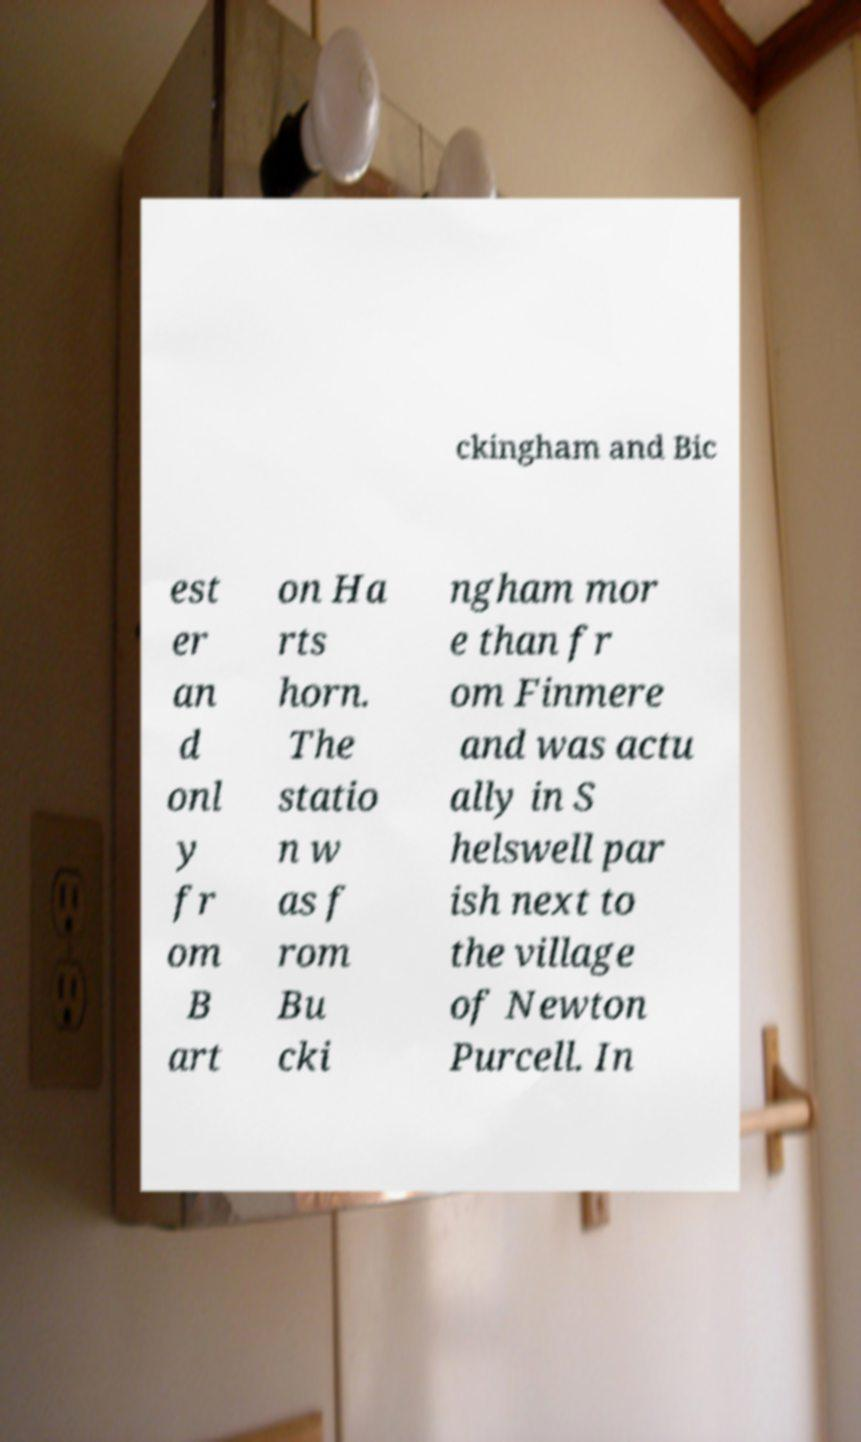What messages or text are displayed in this image? I need them in a readable, typed format. ckingham and Bic est er an d onl y fr om B art on Ha rts horn. The statio n w as f rom Bu cki ngham mor e than fr om Finmere and was actu ally in S helswell par ish next to the village of Newton Purcell. In 